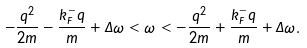Convert formula to latex. <formula><loc_0><loc_0><loc_500><loc_500>- \frac { q ^ { 2 } } { 2 m } - \frac { k _ { F } ^ { - } q } { m } + \Delta \omega < \omega < - \frac { q ^ { 2 } } { 2 m } + \frac { k _ { F } ^ { - } q } { m } + \Delta \omega .</formula> 